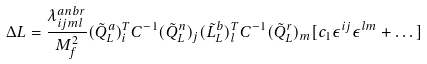<formula> <loc_0><loc_0><loc_500><loc_500>\Delta L = \frac { \lambda _ { i j m l } ^ { a n b r } } { M _ { f } ^ { 2 } } ( \tilde { Q } _ { L } ^ { a } ) ^ { T } _ { i } C ^ { - 1 } ( \tilde { Q } _ { L } ^ { n } ) _ { j } ( \tilde { L } _ { L } ^ { b } ) _ { l } ^ { T } C ^ { - 1 } ( \tilde { Q } _ { L } ^ { r } ) _ { m } [ c _ { 1 } \epsilon ^ { i j } \epsilon ^ { l m } + \dots ]</formula> 